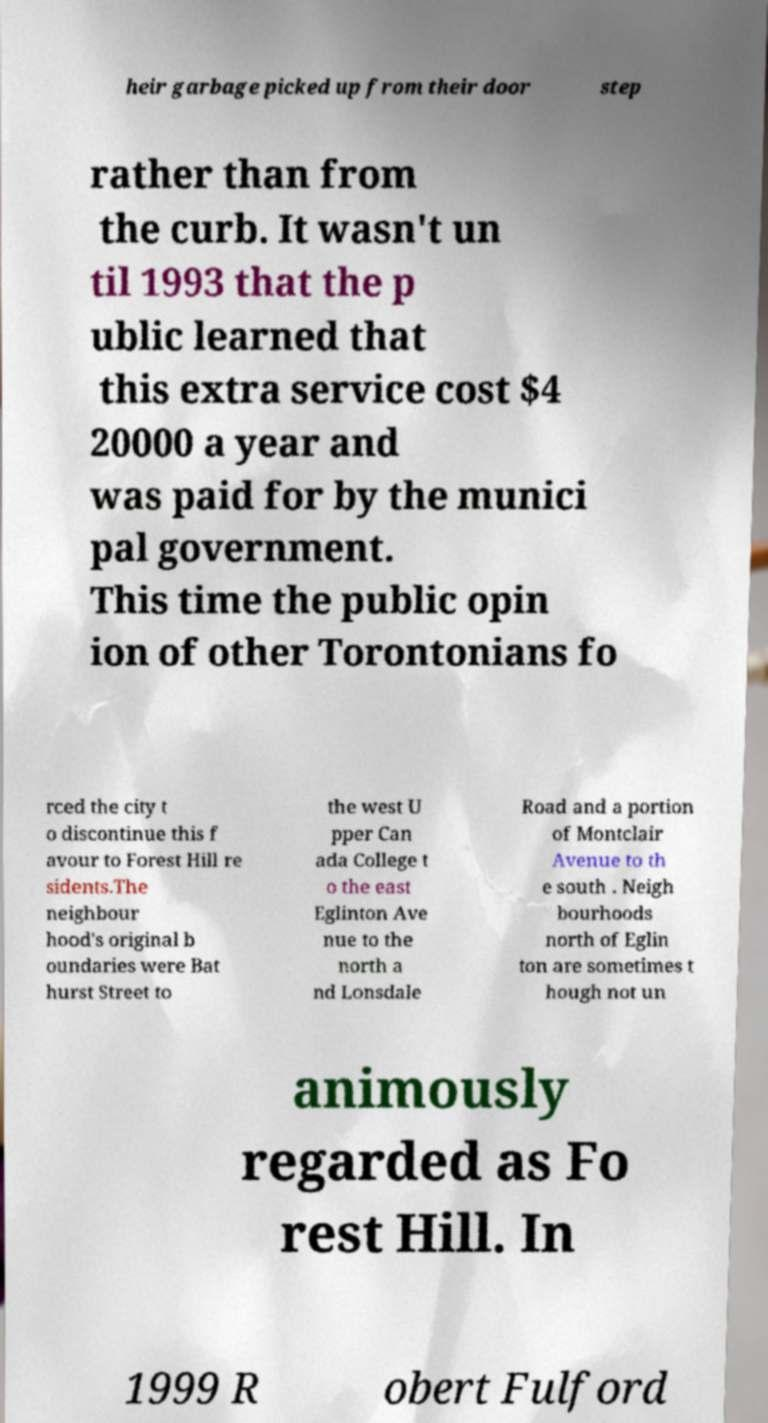Can you accurately transcribe the text from the provided image for me? heir garbage picked up from their door step rather than from the curb. It wasn't un til 1993 that the p ublic learned that this extra service cost $4 20000 a year and was paid for by the munici pal government. This time the public opin ion of other Torontonians fo rced the city t o discontinue this f avour to Forest Hill re sidents.The neighbour hood's original b oundaries were Bat hurst Street to the west U pper Can ada College t o the east Eglinton Ave nue to the north a nd Lonsdale Road and a portion of Montclair Avenue to th e south . Neigh bourhoods north of Eglin ton are sometimes t hough not un animously regarded as Fo rest Hill. In 1999 R obert Fulford 